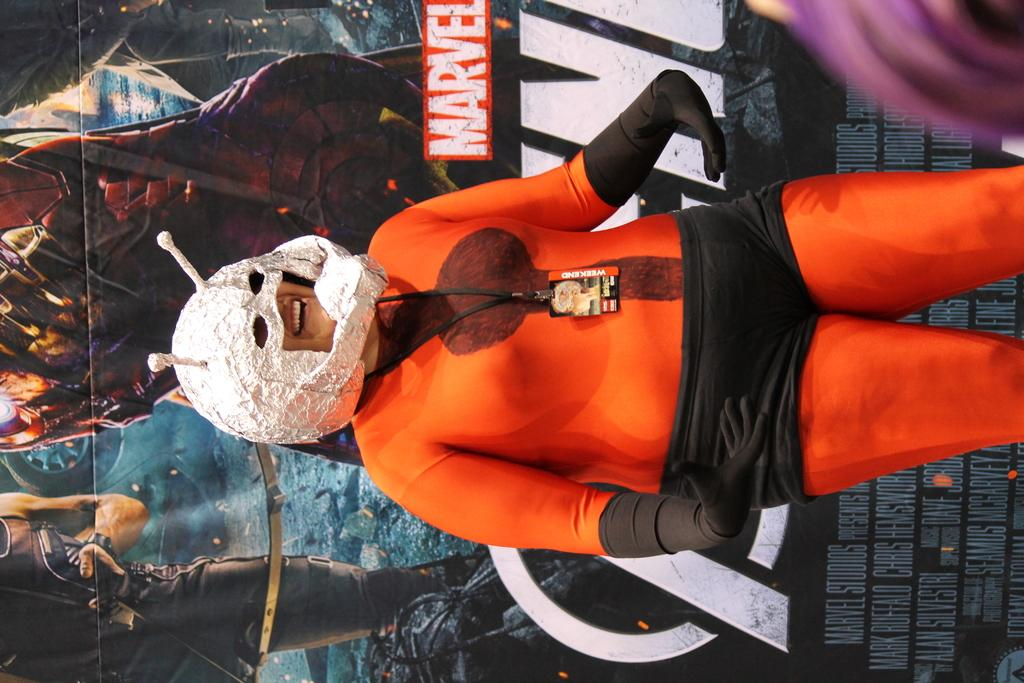Who is present in the image? There is a woman in the image. What is the woman wearing? The woman is wearing a dress. What color is the dress? The dress is in orange color. What is the woman's facial expression? The woman is smiling. What can be seen in the background of the image? There is a banner of a movie in the background. What type of door is visible in the image? There is no door present in the image. Is the woman performing on a stage in the image? There is no stage present in the image. 